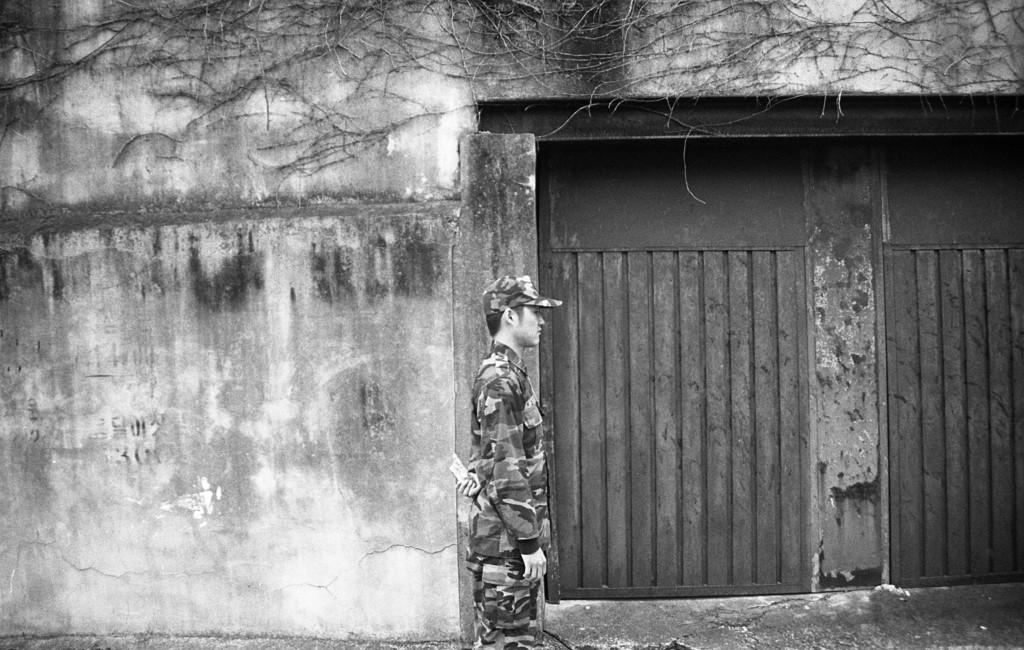What is the main subject of the image? There is a person in the image. Can you describe the person's attire? The person is wearing a cap. What is the person's posture in the image? The person is standing. What can be seen on the right side of the image? There is a door on the right side of the image. What type of natural feature is visible in the image? There are roots visible on a wall in the image. What type of book is the person holding in the image? There is no book present in the image; the person is only wearing a cap and standing. What is the person using to whip the roots on the wall in the image? There is no whip or any action of whipping in the image; the person is simply standing, and the roots are visible on the wall. 